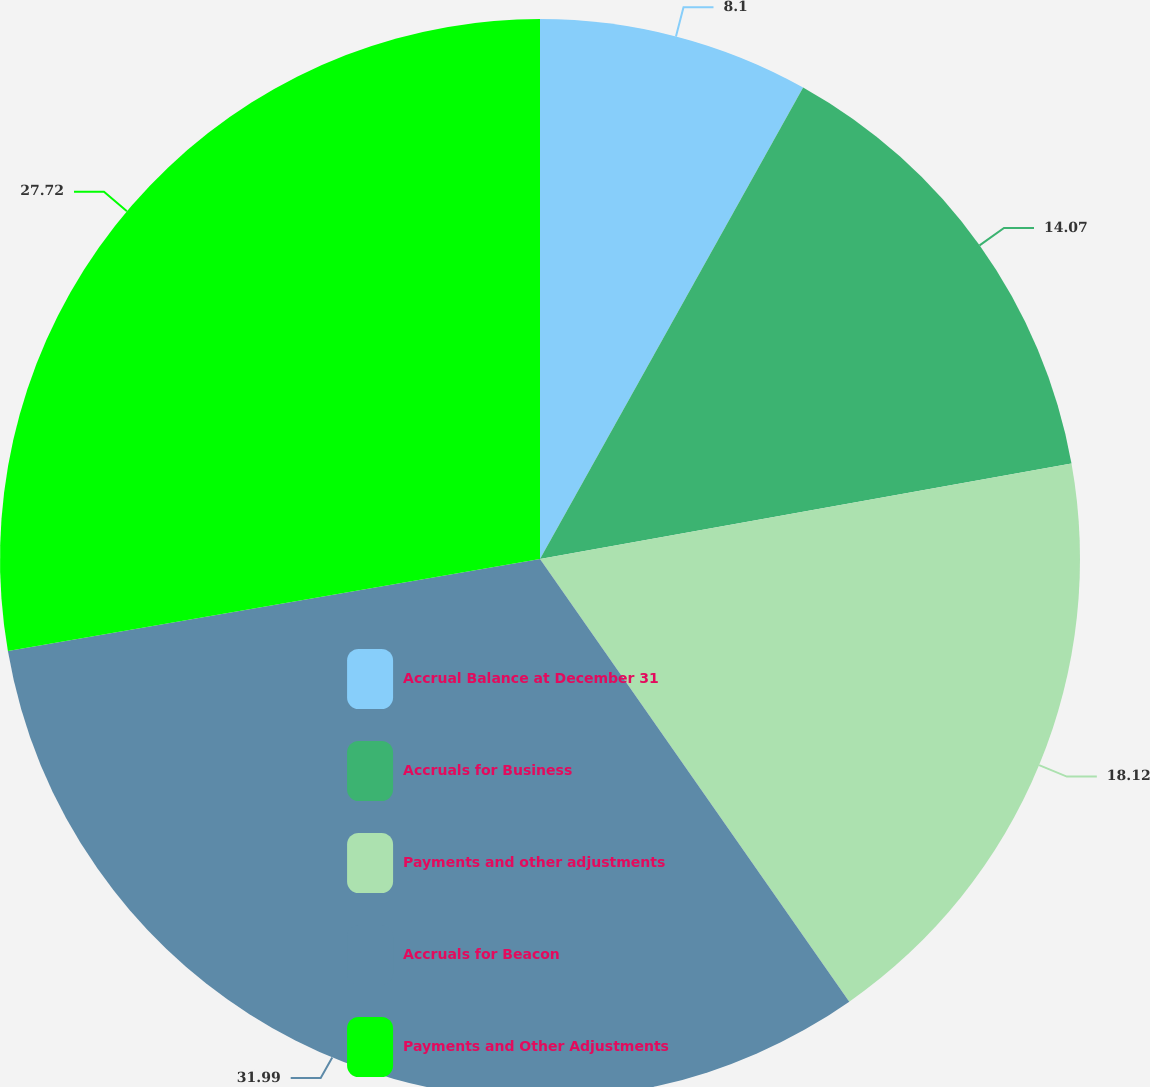<chart> <loc_0><loc_0><loc_500><loc_500><pie_chart><fcel>Accrual Balance at December 31<fcel>Accruals for Business<fcel>Payments and other adjustments<fcel>Accruals for Beacon<fcel>Payments and Other Adjustments<nl><fcel>8.1%<fcel>14.07%<fcel>18.12%<fcel>31.98%<fcel>27.72%<nl></chart> 